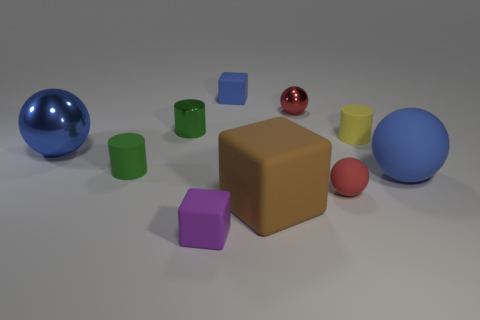There is a large object that is to the right of the yellow rubber object; does it have the same shape as the purple object?
Make the answer very short. No. Are there fewer big red matte blocks than small blue cubes?
Make the answer very short. Yes. There is a yellow object that is the same size as the blue cube; what is its material?
Provide a succinct answer. Rubber. Do the metal cylinder and the tiny cylinder that is left of the metallic cylinder have the same color?
Your answer should be compact. Yes. Is the number of brown matte blocks that are to the left of the large blue matte object less than the number of red things?
Give a very brief answer. Yes. What number of large red objects are there?
Your answer should be very brief. 0. There is a blue object that is behind the small metal object that is on the right side of the large brown cube; what shape is it?
Offer a terse response. Cube. How many red rubber objects are behind the small green matte cylinder?
Offer a very short reply. 0. Is the small purple object made of the same material as the blue ball that is to the right of the green rubber cylinder?
Ensure brevity in your answer.  Yes. Is there a red matte ball of the same size as the yellow cylinder?
Make the answer very short. Yes. 